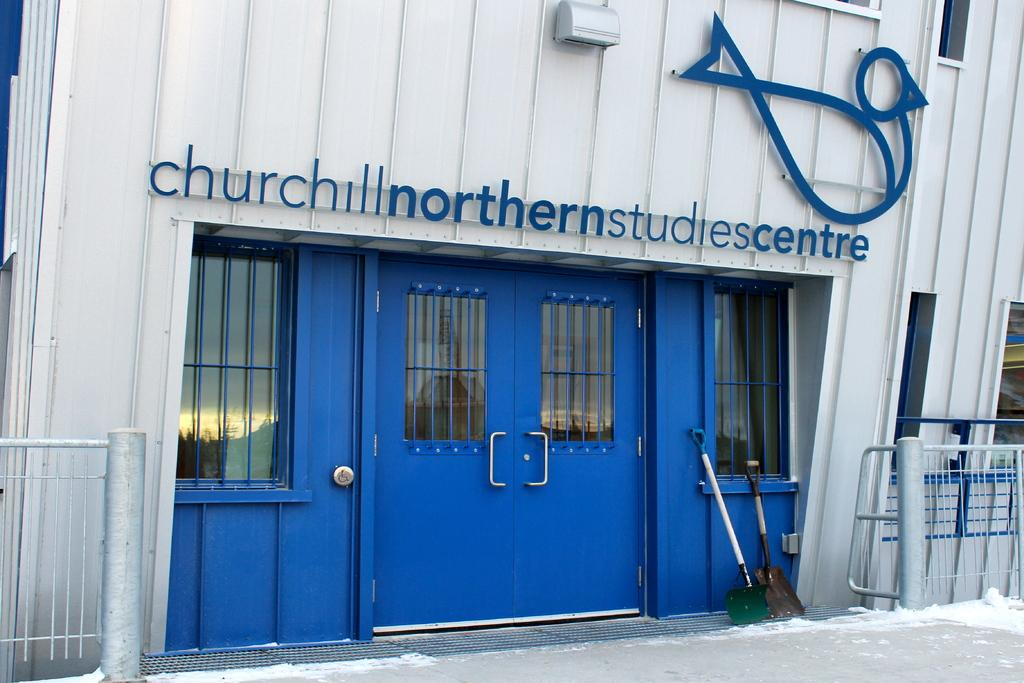<image>
Present a compact description of the photo's key features. the entrance of the churchill nothern studies centre 